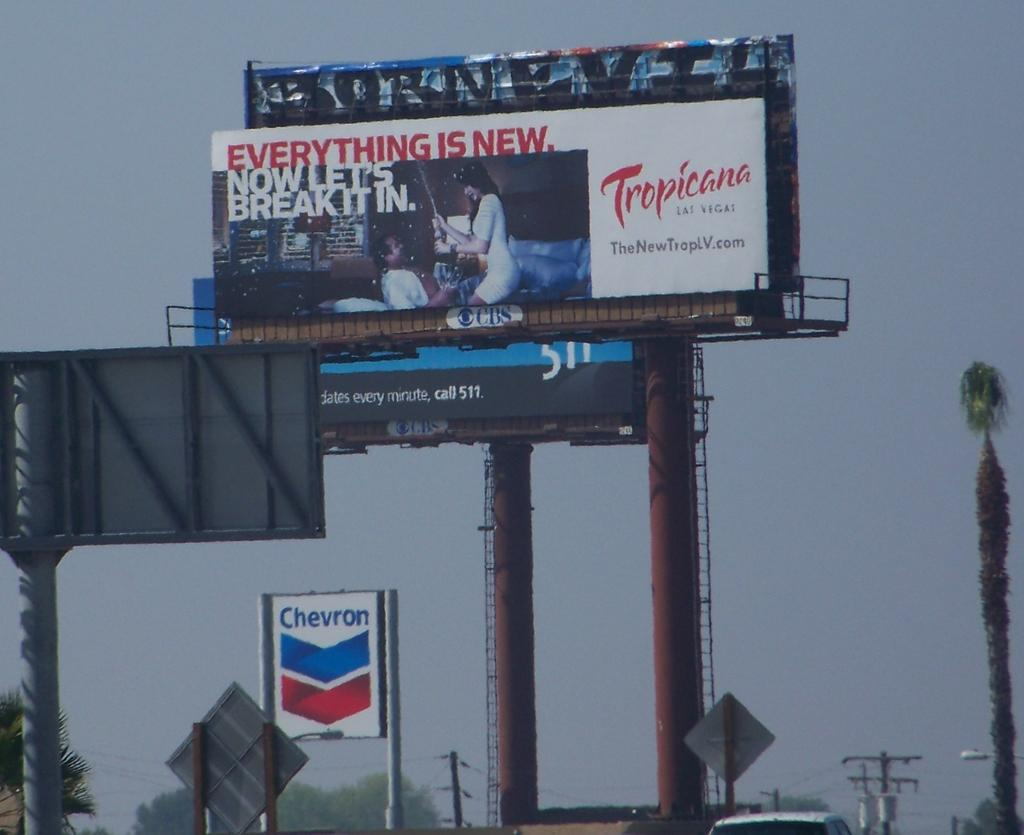<image>
Create a compact narrative representing the image presented. A Chevron sign sits in the distance behind a billboard for Tropicana. 